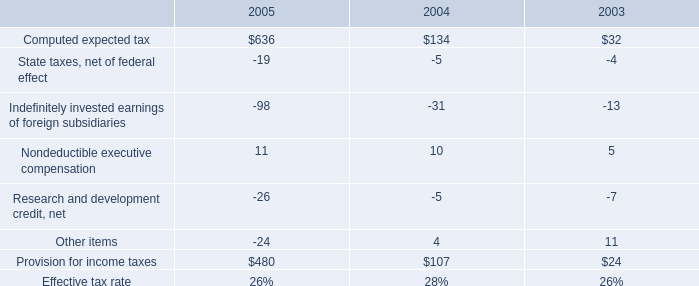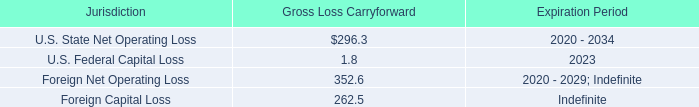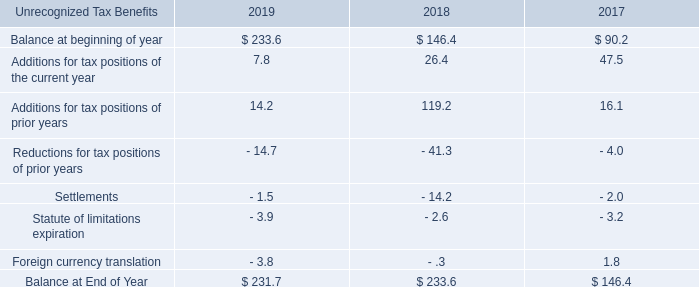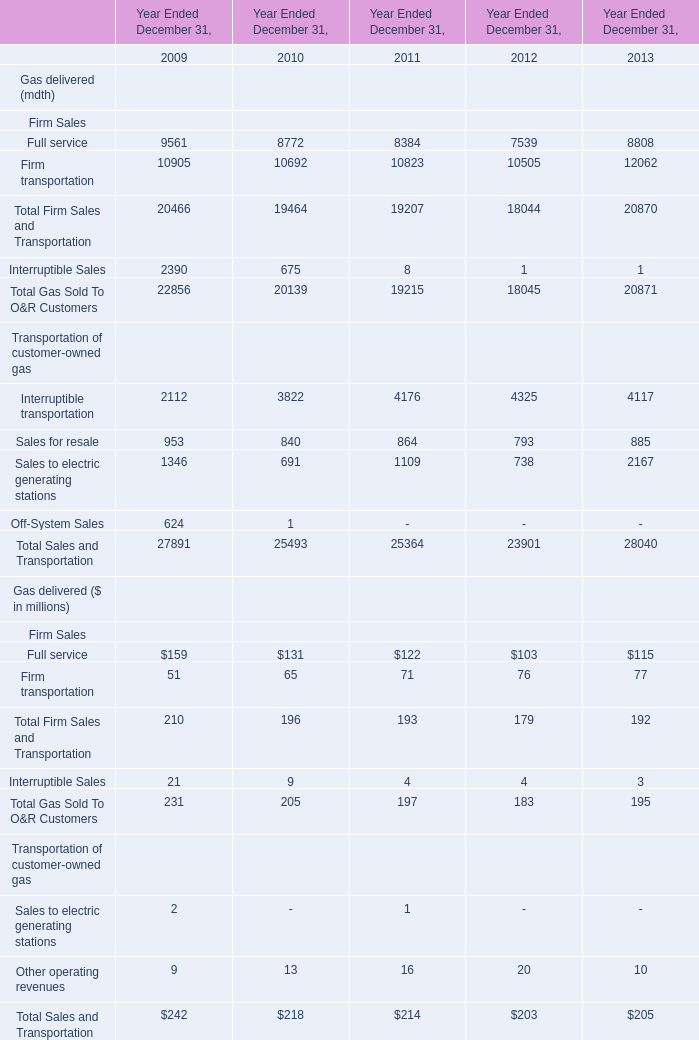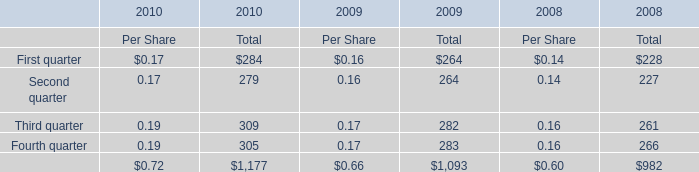What is the sum of Total Sales and Transportation in 2009 for Transportation of customer-owned gas and First quarter in 2010 for Total? (in million) 
Computations: (27891 + 284)
Answer: 28175.0. 